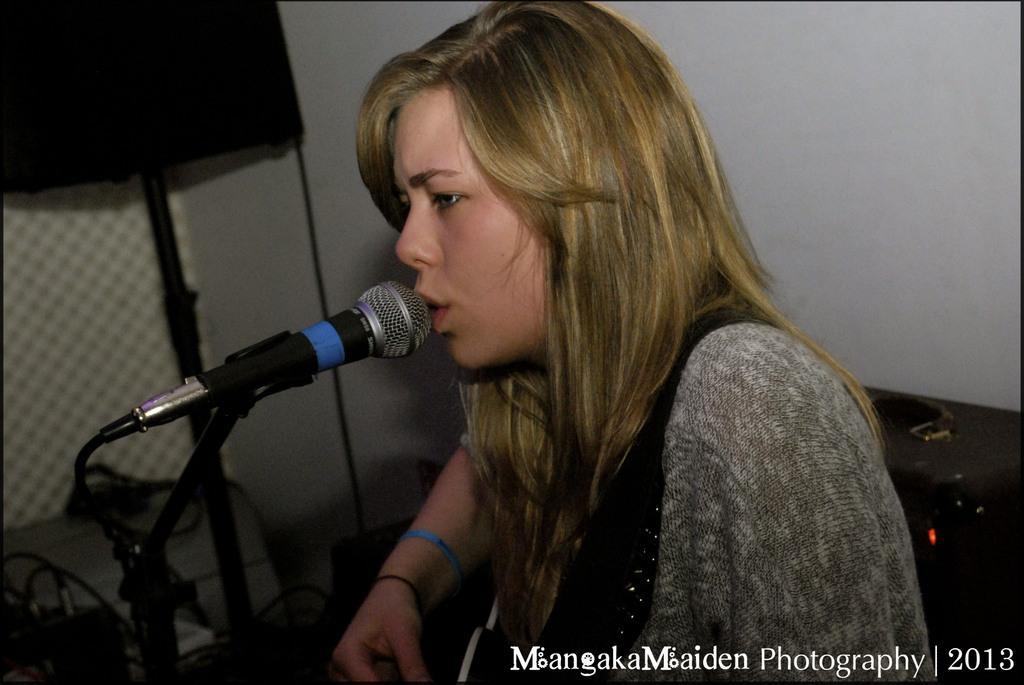In one or two sentences, can you explain what this image depicts? In the center of the image we can see a lady sitting and singing. We can see a mic placed before her. In the background we can see a speaker and a wall. 